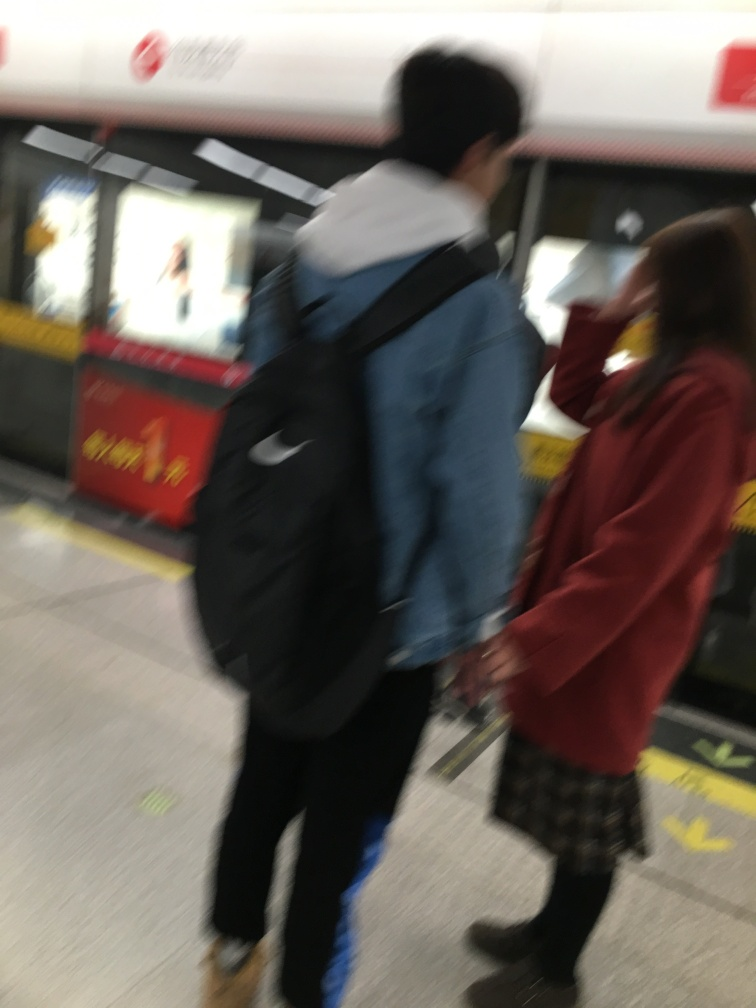What can you infer about the atmosphere of the place? The blurred nature of the image conveys a sense of movement, suggesting a bustling, possibly hurried atmosphere typical of a subway station. The faded signage and platform demarcations are indicative of public transportation. 